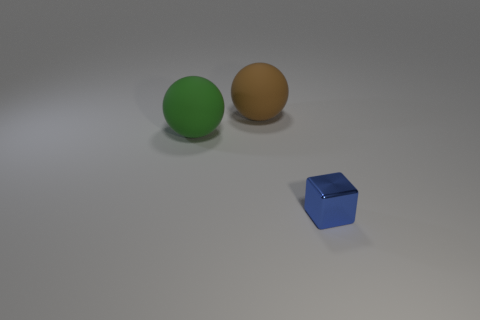What shape is the large thing in front of the brown rubber ball? The object in front of the brown rubber ball is not a shape that can be described in three-dimensional space as it is a flat, two-dimensional representation. The blue object to the side of the balls, however, is a cube. 